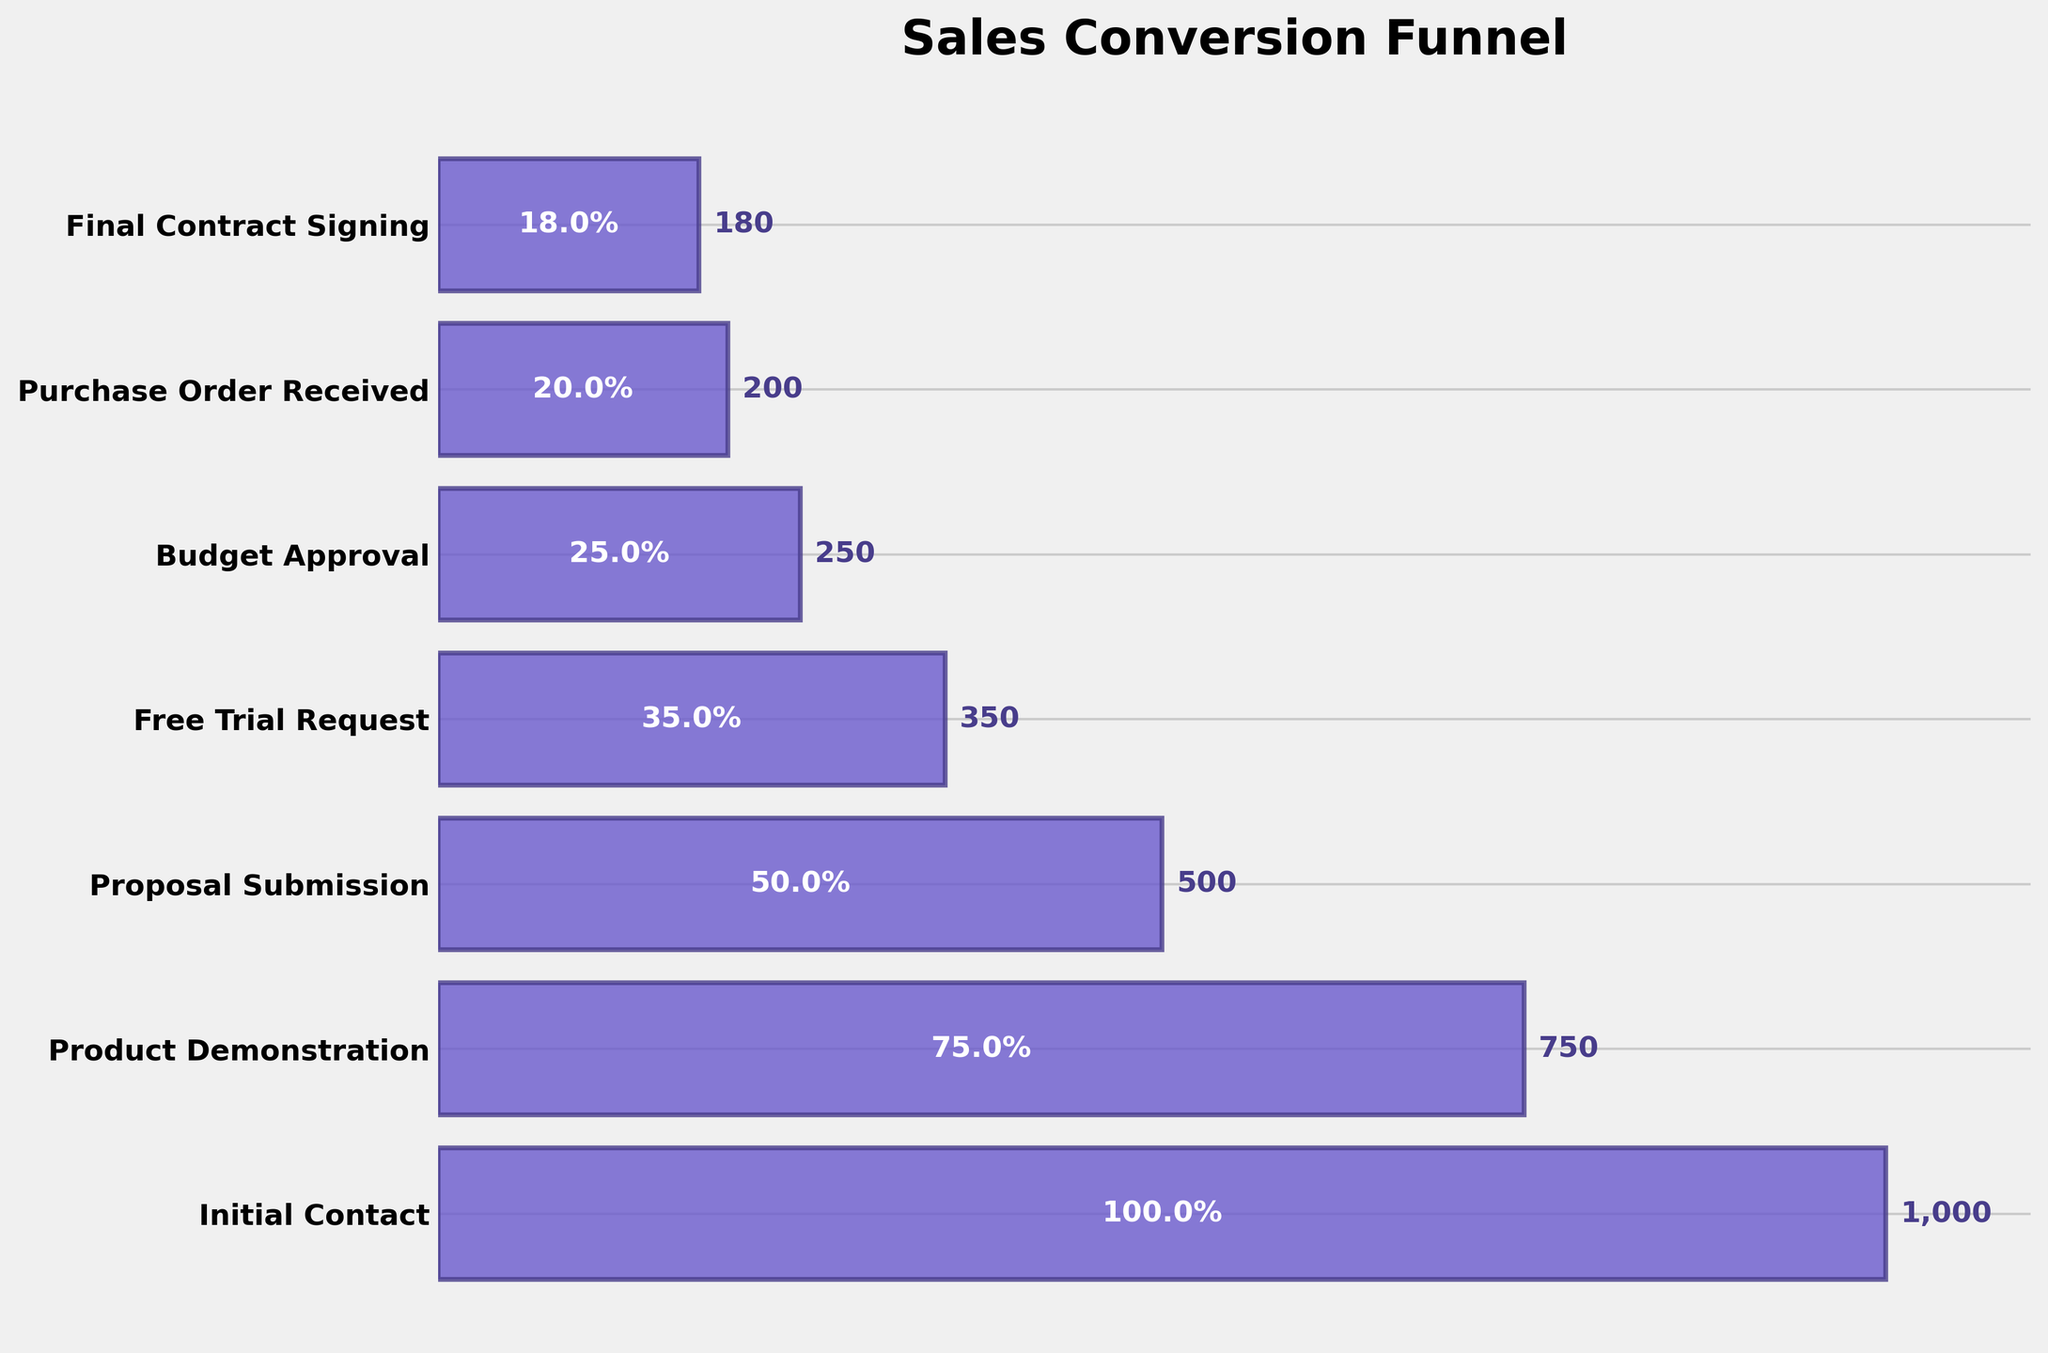what is the title of the chart? The title is usually placed at the top of the figure. From the description, it's indicated at the top.
Answer: Sales Conversion Funnel How many stages are there in the funnel chart? The stages are represented by bars in the funnel. Count the number of bars.
Answer: 7 Which stage has the highest number of prospects? Look at the stage names and check the values of the bars. The bar with the highest value represents the highest number of prospects.
Answer: Initial Contact At which stage do we see exactly half of the Initial Contact prospects remaining? Check the numbers in each stage for the one closest to half of Initial Contact (1000/2 = 500).
Answer: Proposal Submission What percentage of the initial contacts proceed to the Free Trial Request stage? To find the percentage, identify the number of prospects at the Free Trial Request stage, then divide by the number of initial contacts, and multiply by 100.
Answer: 35% How many stages show a decline of more than 200 prospects from the previous stage? Check each stage and subtract the number of prospects from the previous stage. Count the number of stages where this decline exceeds 200.
Answer: 2 Is the percentage drop greater from Product Demonstration to Proposal Submission or from Budget Approval to Purchase Order Received? Calculate the percentage drop for both and compare. From Product Demonstration to Proposal Submission: ((750 - 500) / 750) * 100 = 33.33%. From Budget Approval to Purchase Order Received: ((250 - 200) / 250) * 100 = 20%.
Answer: From Product Demonstration to Proposal Submission How many prospects were lost from Free Trial Request to Purchase Order Received? Subtract the number of prospects at Purchase Order Received from Free Trial Request.
Answer: 150 What is the final conversion rate from Initial Contact to Final Contract Signing? Calculate the final conversion rate by dividing the number of prospects at Final Contract Signing by the number at Initial Contact, then multiply by 100.
Answer: 18% Between which two consecutive stages is the greatest percentage drop in prospects? Calculate the percentage drop between each pair of consecutive stages and compare. The largest drop occurs between the pair showing the highest percentage difference.
Answer: Initial Contact to Product Demonstration 